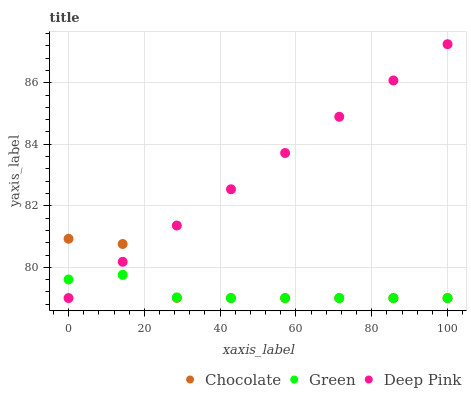Does Green have the minimum area under the curve?
Answer yes or no. Yes. Does Deep Pink have the maximum area under the curve?
Answer yes or no. Yes. Does Chocolate have the minimum area under the curve?
Answer yes or no. No. Does Chocolate have the maximum area under the curve?
Answer yes or no. No. Is Deep Pink the smoothest?
Answer yes or no. Yes. Is Chocolate the roughest?
Answer yes or no. Yes. Is Green the smoothest?
Answer yes or no. No. Is Green the roughest?
Answer yes or no. No. Does Deep Pink have the lowest value?
Answer yes or no. Yes. Does Deep Pink have the highest value?
Answer yes or no. Yes. Does Chocolate have the highest value?
Answer yes or no. No. Does Green intersect Deep Pink?
Answer yes or no. Yes. Is Green less than Deep Pink?
Answer yes or no. No. Is Green greater than Deep Pink?
Answer yes or no. No. 